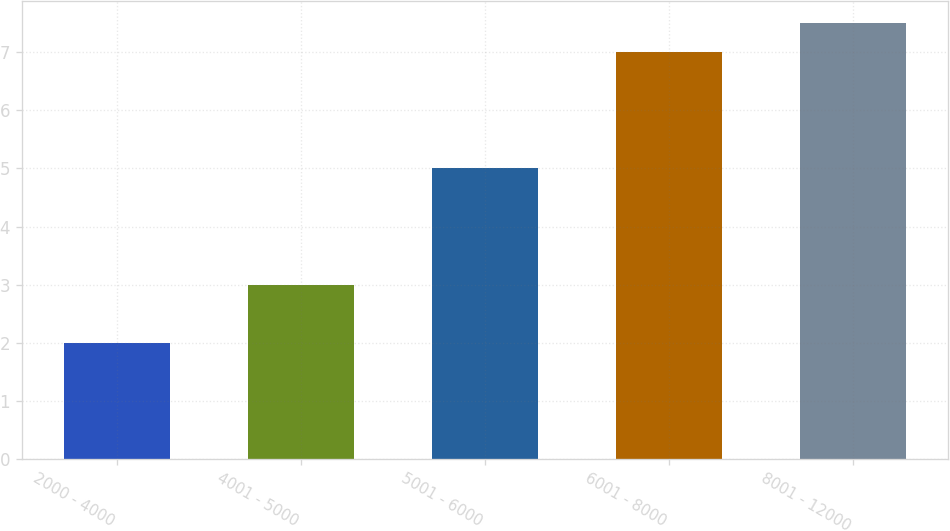Convert chart. <chart><loc_0><loc_0><loc_500><loc_500><bar_chart><fcel>2000 - 4000<fcel>4001 - 5000<fcel>5001 - 6000<fcel>6001 - 8000<fcel>8001 - 12000<nl><fcel>2<fcel>3<fcel>5<fcel>7<fcel>7.5<nl></chart> 